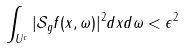Convert formula to latex. <formula><loc_0><loc_0><loc_500><loc_500>\int _ { U ^ { c } } | \mathcal { S } _ { g } f ( x , \omega ) | ^ { 2 } d x d \omega < \epsilon ^ { 2 }</formula> 